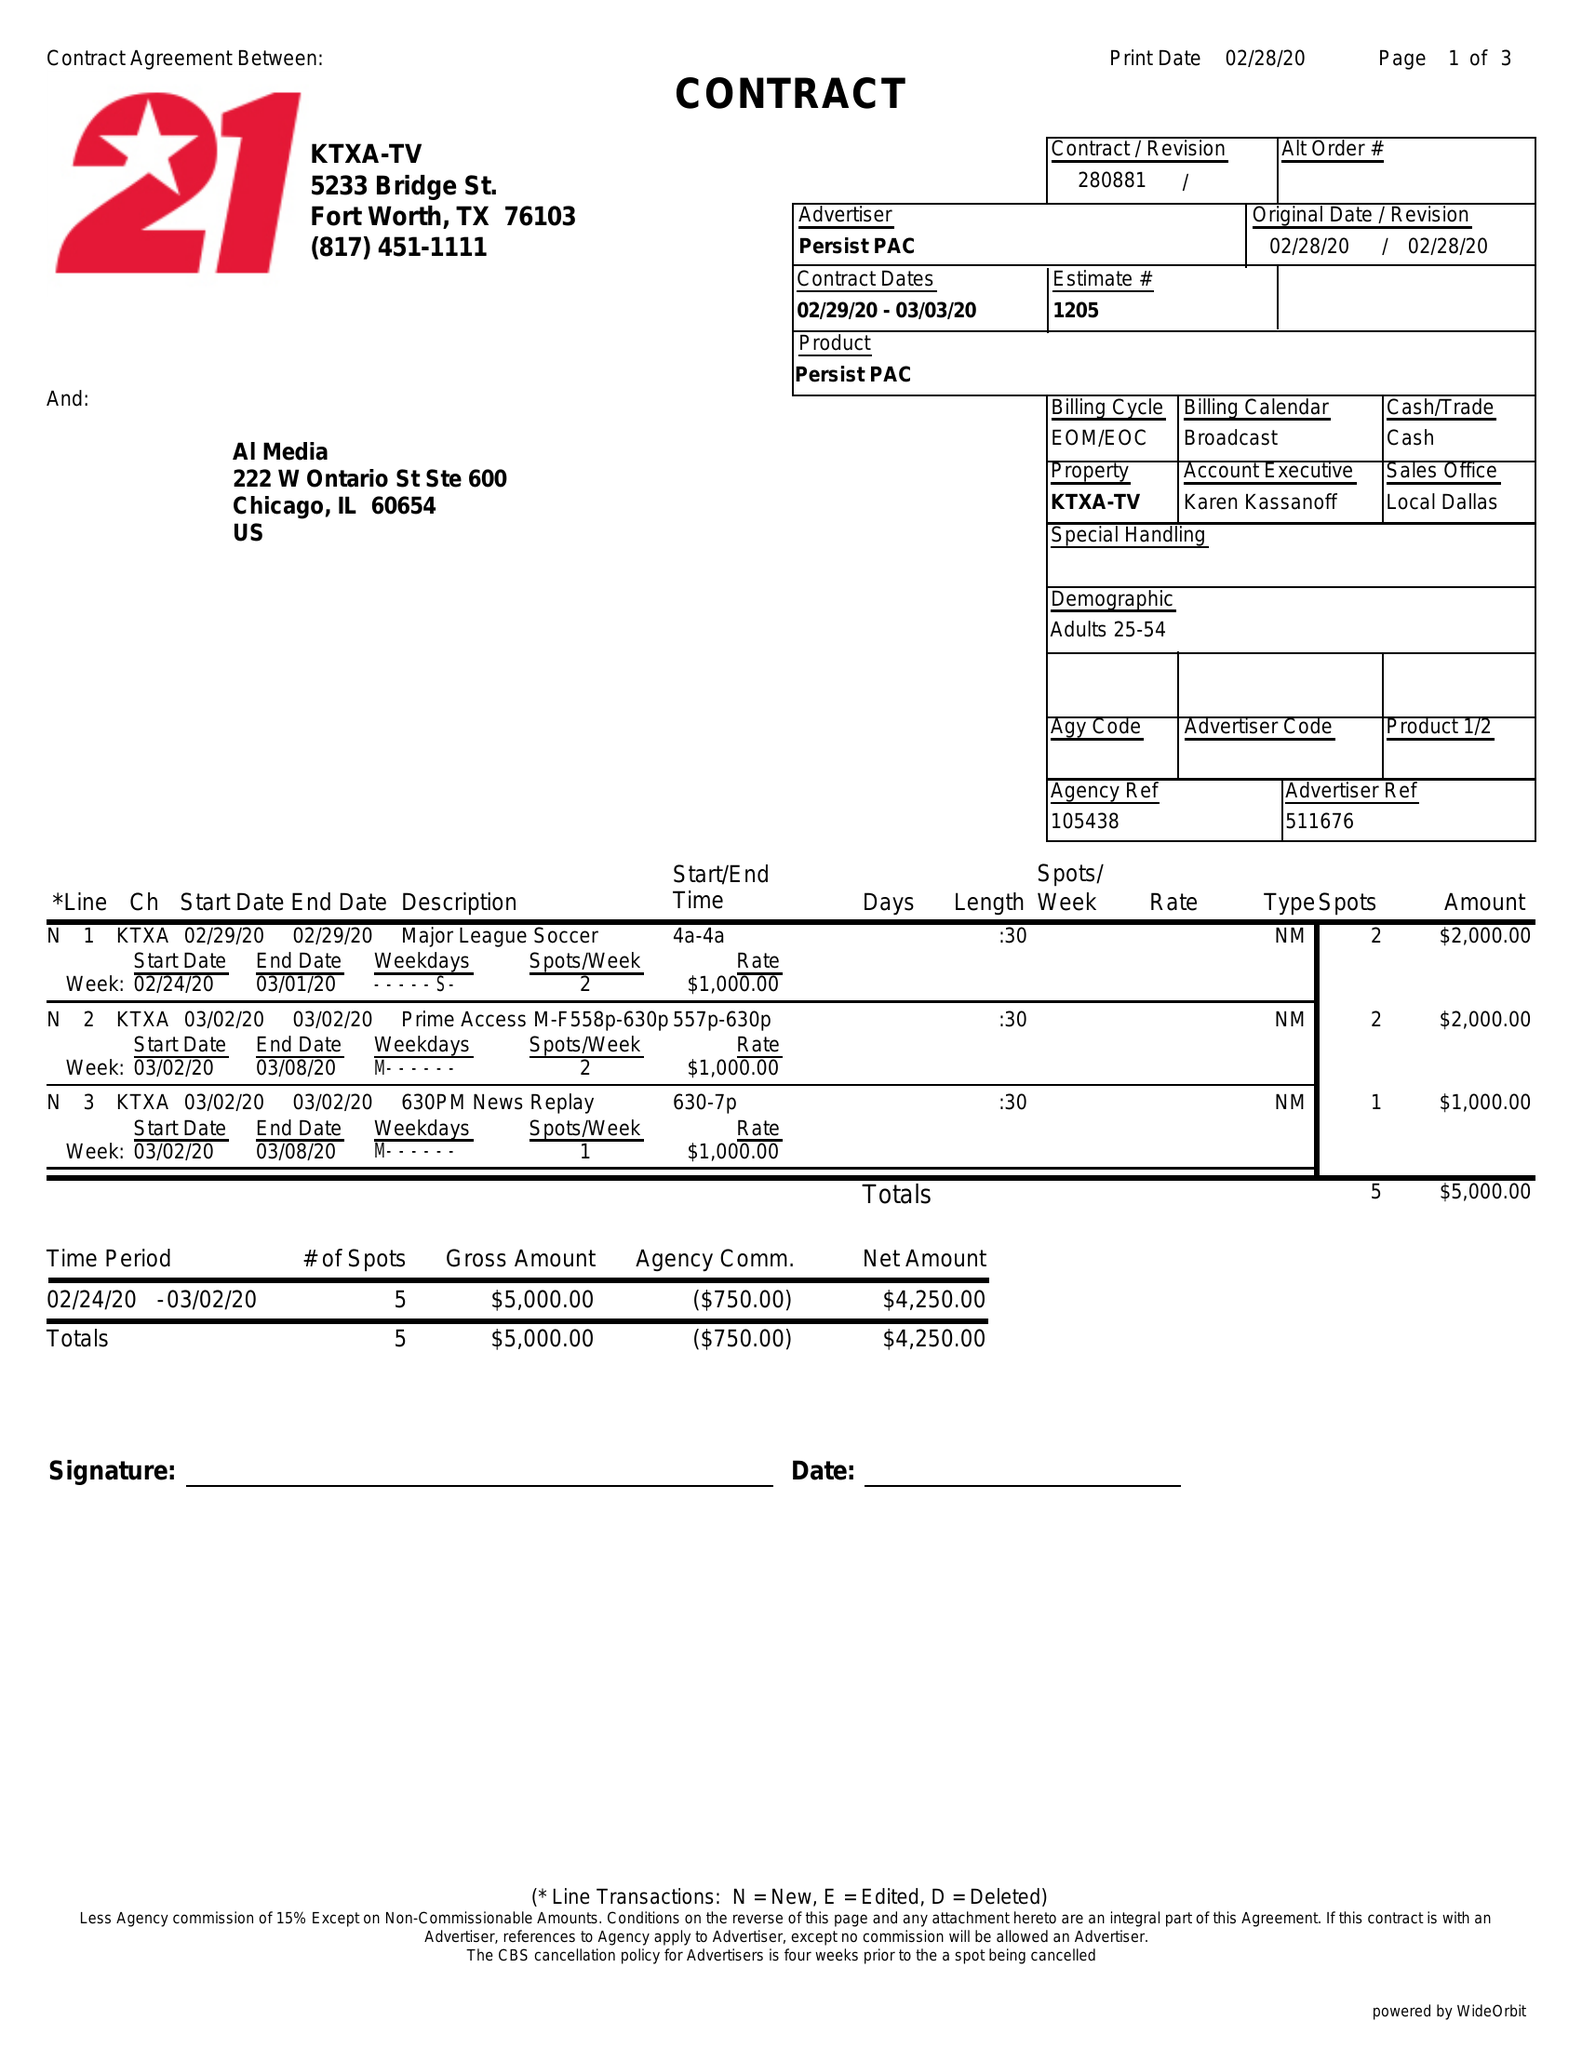What is the value for the flight_from?
Answer the question using a single word or phrase. 02/29/20 